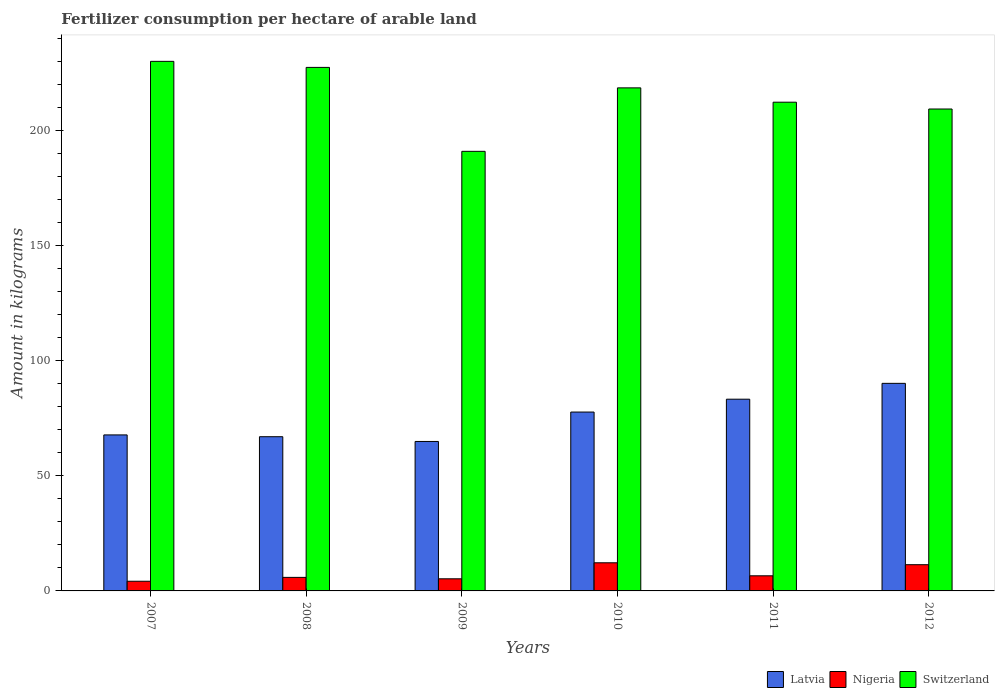How many different coloured bars are there?
Provide a succinct answer. 3. Are the number of bars per tick equal to the number of legend labels?
Keep it short and to the point. Yes. Are the number of bars on each tick of the X-axis equal?
Make the answer very short. Yes. How many bars are there on the 4th tick from the right?
Your answer should be very brief. 3. What is the label of the 2nd group of bars from the left?
Your answer should be compact. 2008. In how many cases, is the number of bars for a given year not equal to the number of legend labels?
Keep it short and to the point. 0. What is the amount of fertilizer consumption in Switzerland in 2012?
Your answer should be compact. 209.21. Across all years, what is the maximum amount of fertilizer consumption in Nigeria?
Provide a short and direct response. 12.21. Across all years, what is the minimum amount of fertilizer consumption in Switzerland?
Your response must be concise. 190.83. In which year was the amount of fertilizer consumption in Nigeria maximum?
Your answer should be very brief. 2010. In which year was the amount of fertilizer consumption in Switzerland minimum?
Your response must be concise. 2009. What is the total amount of fertilizer consumption in Latvia in the graph?
Your answer should be very brief. 450.55. What is the difference between the amount of fertilizer consumption in Latvia in 2009 and that in 2011?
Provide a short and direct response. -18.35. What is the difference between the amount of fertilizer consumption in Switzerland in 2011 and the amount of fertilizer consumption in Latvia in 2008?
Keep it short and to the point. 145.22. What is the average amount of fertilizer consumption in Switzerland per year?
Your response must be concise. 214.63. In the year 2009, what is the difference between the amount of fertilizer consumption in Switzerland and amount of fertilizer consumption in Latvia?
Your answer should be compact. 125.95. In how many years, is the amount of fertilizer consumption in Switzerland greater than 30 kg?
Offer a very short reply. 6. What is the ratio of the amount of fertilizer consumption in Nigeria in 2008 to that in 2009?
Make the answer very short. 1.12. Is the amount of fertilizer consumption in Switzerland in 2010 less than that in 2011?
Offer a very short reply. No. Is the difference between the amount of fertilizer consumption in Switzerland in 2010 and 2012 greater than the difference between the amount of fertilizer consumption in Latvia in 2010 and 2012?
Provide a succinct answer. Yes. What is the difference between the highest and the second highest amount of fertilizer consumption in Switzerland?
Offer a terse response. 2.62. What is the difference between the highest and the lowest amount of fertilizer consumption in Latvia?
Provide a succinct answer. 25.23. Is the sum of the amount of fertilizer consumption in Switzerland in 2007 and 2008 greater than the maximum amount of fertilizer consumption in Latvia across all years?
Your answer should be compact. Yes. What does the 2nd bar from the left in 2012 represents?
Your answer should be very brief. Nigeria. What does the 3rd bar from the right in 2012 represents?
Provide a short and direct response. Latvia. Does the graph contain any zero values?
Offer a very short reply. No. How many legend labels are there?
Ensure brevity in your answer.  3. How are the legend labels stacked?
Provide a succinct answer. Horizontal. What is the title of the graph?
Provide a succinct answer. Fertilizer consumption per hectare of arable land. What is the label or title of the X-axis?
Give a very brief answer. Years. What is the label or title of the Y-axis?
Provide a succinct answer. Amount in kilograms. What is the Amount in kilograms in Latvia in 2007?
Provide a short and direct response. 67.72. What is the Amount in kilograms in Nigeria in 2007?
Ensure brevity in your answer.  4.21. What is the Amount in kilograms in Switzerland in 2007?
Your response must be concise. 229.9. What is the Amount in kilograms of Latvia in 2008?
Give a very brief answer. 66.95. What is the Amount in kilograms of Nigeria in 2008?
Offer a very short reply. 5.88. What is the Amount in kilograms of Switzerland in 2008?
Offer a very short reply. 227.27. What is the Amount in kilograms of Latvia in 2009?
Offer a terse response. 64.88. What is the Amount in kilograms of Nigeria in 2009?
Ensure brevity in your answer.  5.26. What is the Amount in kilograms of Switzerland in 2009?
Give a very brief answer. 190.83. What is the Amount in kilograms in Latvia in 2010?
Provide a short and direct response. 77.65. What is the Amount in kilograms of Nigeria in 2010?
Offer a terse response. 12.21. What is the Amount in kilograms in Switzerland in 2010?
Offer a terse response. 218.38. What is the Amount in kilograms of Latvia in 2011?
Give a very brief answer. 83.23. What is the Amount in kilograms of Nigeria in 2011?
Offer a very short reply. 6.56. What is the Amount in kilograms in Switzerland in 2011?
Make the answer very short. 212.16. What is the Amount in kilograms of Latvia in 2012?
Make the answer very short. 90.11. What is the Amount in kilograms of Nigeria in 2012?
Your answer should be compact. 11.38. What is the Amount in kilograms of Switzerland in 2012?
Provide a succinct answer. 209.21. Across all years, what is the maximum Amount in kilograms in Latvia?
Offer a very short reply. 90.11. Across all years, what is the maximum Amount in kilograms of Nigeria?
Your answer should be compact. 12.21. Across all years, what is the maximum Amount in kilograms in Switzerland?
Ensure brevity in your answer.  229.9. Across all years, what is the minimum Amount in kilograms in Latvia?
Ensure brevity in your answer.  64.88. Across all years, what is the minimum Amount in kilograms of Nigeria?
Keep it short and to the point. 4.21. Across all years, what is the minimum Amount in kilograms of Switzerland?
Keep it short and to the point. 190.83. What is the total Amount in kilograms in Latvia in the graph?
Offer a very short reply. 450.55. What is the total Amount in kilograms in Nigeria in the graph?
Your answer should be compact. 45.5. What is the total Amount in kilograms of Switzerland in the graph?
Your response must be concise. 1287.75. What is the difference between the Amount in kilograms in Latvia in 2007 and that in 2008?
Your answer should be compact. 0.78. What is the difference between the Amount in kilograms of Nigeria in 2007 and that in 2008?
Provide a short and direct response. -1.67. What is the difference between the Amount in kilograms of Switzerland in 2007 and that in 2008?
Keep it short and to the point. 2.62. What is the difference between the Amount in kilograms of Latvia in 2007 and that in 2009?
Provide a succinct answer. 2.84. What is the difference between the Amount in kilograms in Nigeria in 2007 and that in 2009?
Keep it short and to the point. -1.06. What is the difference between the Amount in kilograms in Switzerland in 2007 and that in 2009?
Your answer should be compact. 39.07. What is the difference between the Amount in kilograms of Latvia in 2007 and that in 2010?
Your response must be concise. -9.92. What is the difference between the Amount in kilograms of Nigeria in 2007 and that in 2010?
Your answer should be very brief. -8.01. What is the difference between the Amount in kilograms in Switzerland in 2007 and that in 2010?
Provide a succinct answer. 11.51. What is the difference between the Amount in kilograms of Latvia in 2007 and that in 2011?
Your answer should be very brief. -15.51. What is the difference between the Amount in kilograms in Nigeria in 2007 and that in 2011?
Give a very brief answer. -2.36. What is the difference between the Amount in kilograms in Switzerland in 2007 and that in 2011?
Your response must be concise. 17.73. What is the difference between the Amount in kilograms of Latvia in 2007 and that in 2012?
Make the answer very short. -22.39. What is the difference between the Amount in kilograms of Nigeria in 2007 and that in 2012?
Offer a very short reply. -7.18. What is the difference between the Amount in kilograms in Switzerland in 2007 and that in 2012?
Offer a very short reply. 20.69. What is the difference between the Amount in kilograms in Latvia in 2008 and that in 2009?
Your answer should be very brief. 2.06. What is the difference between the Amount in kilograms in Nigeria in 2008 and that in 2009?
Your response must be concise. 0.62. What is the difference between the Amount in kilograms of Switzerland in 2008 and that in 2009?
Provide a short and direct response. 36.44. What is the difference between the Amount in kilograms in Latvia in 2008 and that in 2010?
Offer a terse response. -10.7. What is the difference between the Amount in kilograms of Nigeria in 2008 and that in 2010?
Give a very brief answer. -6.34. What is the difference between the Amount in kilograms of Switzerland in 2008 and that in 2010?
Provide a succinct answer. 8.89. What is the difference between the Amount in kilograms in Latvia in 2008 and that in 2011?
Offer a terse response. -16.29. What is the difference between the Amount in kilograms in Nigeria in 2008 and that in 2011?
Your response must be concise. -0.68. What is the difference between the Amount in kilograms in Switzerland in 2008 and that in 2011?
Offer a very short reply. 15.11. What is the difference between the Amount in kilograms in Latvia in 2008 and that in 2012?
Keep it short and to the point. -23.16. What is the difference between the Amount in kilograms of Nigeria in 2008 and that in 2012?
Make the answer very short. -5.51. What is the difference between the Amount in kilograms of Switzerland in 2008 and that in 2012?
Offer a terse response. 18.07. What is the difference between the Amount in kilograms in Latvia in 2009 and that in 2010?
Make the answer very short. -12.76. What is the difference between the Amount in kilograms of Nigeria in 2009 and that in 2010?
Your response must be concise. -6.95. What is the difference between the Amount in kilograms of Switzerland in 2009 and that in 2010?
Give a very brief answer. -27.55. What is the difference between the Amount in kilograms of Latvia in 2009 and that in 2011?
Your answer should be compact. -18.35. What is the difference between the Amount in kilograms in Nigeria in 2009 and that in 2011?
Provide a short and direct response. -1.3. What is the difference between the Amount in kilograms of Switzerland in 2009 and that in 2011?
Make the answer very short. -21.33. What is the difference between the Amount in kilograms of Latvia in 2009 and that in 2012?
Provide a short and direct response. -25.23. What is the difference between the Amount in kilograms in Nigeria in 2009 and that in 2012?
Keep it short and to the point. -6.12. What is the difference between the Amount in kilograms in Switzerland in 2009 and that in 2012?
Your answer should be very brief. -18.38. What is the difference between the Amount in kilograms in Latvia in 2010 and that in 2011?
Keep it short and to the point. -5.58. What is the difference between the Amount in kilograms in Nigeria in 2010 and that in 2011?
Your answer should be compact. 5.65. What is the difference between the Amount in kilograms of Switzerland in 2010 and that in 2011?
Provide a short and direct response. 6.22. What is the difference between the Amount in kilograms in Latvia in 2010 and that in 2012?
Your answer should be compact. -12.46. What is the difference between the Amount in kilograms in Nigeria in 2010 and that in 2012?
Keep it short and to the point. 0.83. What is the difference between the Amount in kilograms in Switzerland in 2010 and that in 2012?
Your answer should be very brief. 9.18. What is the difference between the Amount in kilograms of Latvia in 2011 and that in 2012?
Ensure brevity in your answer.  -6.88. What is the difference between the Amount in kilograms of Nigeria in 2011 and that in 2012?
Give a very brief answer. -4.82. What is the difference between the Amount in kilograms in Switzerland in 2011 and that in 2012?
Ensure brevity in your answer.  2.96. What is the difference between the Amount in kilograms of Latvia in 2007 and the Amount in kilograms of Nigeria in 2008?
Keep it short and to the point. 61.85. What is the difference between the Amount in kilograms of Latvia in 2007 and the Amount in kilograms of Switzerland in 2008?
Ensure brevity in your answer.  -159.55. What is the difference between the Amount in kilograms in Nigeria in 2007 and the Amount in kilograms in Switzerland in 2008?
Provide a short and direct response. -223.07. What is the difference between the Amount in kilograms of Latvia in 2007 and the Amount in kilograms of Nigeria in 2009?
Ensure brevity in your answer.  62.46. What is the difference between the Amount in kilograms in Latvia in 2007 and the Amount in kilograms in Switzerland in 2009?
Ensure brevity in your answer.  -123.11. What is the difference between the Amount in kilograms of Nigeria in 2007 and the Amount in kilograms of Switzerland in 2009?
Provide a succinct answer. -186.62. What is the difference between the Amount in kilograms in Latvia in 2007 and the Amount in kilograms in Nigeria in 2010?
Keep it short and to the point. 55.51. What is the difference between the Amount in kilograms of Latvia in 2007 and the Amount in kilograms of Switzerland in 2010?
Your answer should be very brief. -150.66. What is the difference between the Amount in kilograms of Nigeria in 2007 and the Amount in kilograms of Switzerland in 2010?
Give a very brief answer. -214.18. What is the difference between the Amount in kilograms in Latvia in 2007 and the Amount in kilograms in Nigeria in 2011?
Give a very brief answer. 61.16. What is the difference between the Amount in kilograms of Latvia in 2007 and the Amount in kilograms of Switzerland in 2011?
Your answer should be very brief. -144.44. What is the difference between the Amount in kilograms of Nigeria in 2007 and the Amount in kilograms of Switzerland in 2011?
Offer a very short reply. -207.96. What is the difference between the Amount in kilograms of Latvia in 2007 and the Amount in kilograms of Nigeria in 2012?
Your answer should be compact. 56.34. What is the difference between the Amount in kilograms in Latvia in 2007 and the Amount in kilograms in Switzerland in 2012?
Keep it short and to the point. -141.48. What is the difference between the Amount in kilograms in Nigeria in 2007 and the Amount in kilograms in Switzerland in 2012?
Your answer should be compact. -205. What is the difference between the Amount in kilograms in Latvia in 2008 and the Amount in kilograms in Nigeria in 2009?
Keep it short and to the point. 61.69. What is the difference between the Amount in kilograms in Latvia in 2008 and the Amount in kilograms in Switzerland in 2009?
Make the answer very short. -123.88. What is the difference between the Amount in kilograms of Nigeria in 2008 and the Amount in kilograms of Switzerland in 2009?
Provide a succinct answer. -184.95. What is the difference between the Amount in kilograms in Latvia in 2008 and the Amount in kilograms in Nigeria in 2010?
Provide a succinct answer. 54.73. What is the difference between the Amount in kilograms of Latvia in 2008 and the Amount in kilograms of Switzerland in 2010?
Offer a very short reply. -151.44. What is the difference between the Amount in kilograms of Nigeria in 2008 and the Amount in kilograms of Switzerland in 2010?
Your answer should be compact. -212.51. What is the difference between the Amount in kilograms in Latvia in 2008 and the Amount in kilograms in Nigeria in 2011?
Your response must be concise. 60.39. What is the difference between the Amount in kilograms of Latvia in 2008 and the Amount in kilograms of Switzerland in 2011?
Offer a very short reply. -145.22. What is the difference between the Amount in kilograms of Nigeria in 2008 and the Amount in kilograms of Switzerland in 2011?
Your answer should be very brief. -206.29. What is the difference between the Amount in kilograms in Latvia in 2008 and the Amount in kilograms in Nigeria in 2012?
Provide a short and direct response. 55.56. What is the difference between the Amount in kilograms in Latvia in 2008 and the Amount in kilograms in Switzerland in 2012?
Keep it short and to the point. -142.26. What is the difference between the Amount in kilograms of Nigeria in 2008 and the Amount in kilograms of Switzerland in 2012?
Offer a very short reply. -203.33. What is the difference between the Amount in kilograms in Latvia in 2009 and the Amount in kilograms in Nigeria in 2010?
Provide a succinct answer. 52.67. What is the difference between the Amount in kilograms in Latvia in 2009 and the Amount in kilograms in Switzerland in 2010?
Provide a succinct answer. -153.5. What is the difference between the Amount in kilograms in Nigeria in 2009 and the Amount in kilograms in Switzerland in 2010?
Your response must be concise. -213.12. What is the difference between the Amount in kilograms of Latvia in 2009 and the Amount in kilograms of Nigeria in 2011?
Your answer should be compact. 58.32. What is the difference between the Amount in kilograms of Latvia in 2009 and the Amount in kilograms of Switzerland in 2011?
Keep it short and to the point. -147.28. What is the difference between the Amount in kilograms of Nigeria in 2009 and the Amount in kilograms of Switzerland in 2011?
Offer a very short reply. -206.9. What is the difference between the Amount in kilograms in Latvia in 2009 and the Amount in kilograms in Nigeria in 2012?
Your answer should be very brief. 53.5. What is the difference between the Amount in kilograms of Latvia in 2009 and the Amount in kilograms of Switzerland in 2012?
Offer a terse response. -144.32. What is the difference between the Amount in kilograms of Nigeria in 2009 and the Amount in kilograms of Switzerland in 2012?
Give a very brief answer. -203.95. What is the difference between the Amount in kilograms in Latvia in 2010 and the Amount in kilograms in Nigeria in 2011?
Your response must be concise. 71.09. What is the difference between the Amount in kilograms of Latvia in 2010 and the Amount in kilograms of Switzerland in 2011?
Your response must be concise. -134.52. What is the difference between the Amount in kilograms in Nigeria in 2010 and the Amount in kilograms in Switzerland in 2011?
Give a very brief answer. -199.95. What is the difference between the Amount in kilograms in Latvia in 2010 and the Amount in kilograms in Nigeria in 2012?
Keep it short and to the point. 66.26. What is the difference between the Amount in kilograms of Latvia in 2010 and the Amount in kilograms of Switzerland in 2012?
Offer a very short reply. -131.56. What is the difference between the Amount in kilograms of Nigeria in 2010 and the Amount in kilograms of Switzerland in 2012?
Give a very brief answer. -196.99. What is the difference between the Amount in kilograms of Latvia in 2011 and the Amount in kilograms of Nigeria in 2012?
Your answer should be very brief. 71.85. What is the difference between the Amount in kilograms of Latvia in 2011 and the Amount in kilograms of Switzerland in 2012?
Provide a short and direct response. -125.98. What is the difference between the Amount in kilograms in Nigeria in 2011 and the Amount in kilograms in Switzerland in 2012?
Your response must be concise. -202.65. What is the average Amount in kilograms in Latvia per year?
Provide a succinct answer. 75.09. What is the average Amount in kilograms of Nigeria per year?
Offer a very short reply. 7.58. What is the average Amount in kilograms of Switzerland per year?
Keep it short and to the point. 214.63. In the year 2007, what is the difference between the Amount in kilograms in Latvia and Amount in kilograms in Nigeria?
Keep it short and to the point. 63.52. In the year 2007, what is the difference between the Amount in kilograms in Latvia and Amount in kilograms in Switzerland?
Your answer should be compact. -162.17. In the year 2007, what is the difference between the Amount in kilograms of Nigeria and Amount in kilograms of Switzerland?
Give a very brief answer. -225.69. In the year 2008, what is the difference between the Amount in kilograms of Latvia and Amount in kilograms of Nigeria?
Your answer should be compact. 61.07. In the year 2008, what is the difference between the Amount in kilograms in Latvia and Amount in kilograms in Switzerland?
Ensure brevity in your answer.  -160.33. In the year 2008, what is the difference between the Amount in kilograms of Nigeria and Amount in kilograms of Switzerland?
Your answer should be compact. -221.4. In the year 2009, what is the difference between the Amount in kilograms of Latvia and Amount in kilograms of Nigeria?
Ensure brevity in your answer.  59.62. In the year 2009, what is the difference between the Amount in kilograms in Latvia and Amount in kilograms in Switzerland?
Provide a short and direct response. -125.95. In the year 2009, what is the difference between the Amount in kilograms of Nigeria and Amount in kilograms of Switzerland?
Your answer should be compact. -185.57. In the year 2010, what is the difference between the Amount in kilograms of Latvia and Amount in kilograms of Nigeria?
Provide a short and direct response. 65.43. In the year 2010, what is the difference between the Amount in kilograms of Latvia and Amount in kilograms of Switzerland?
Make the answer very short. -140.74. In the year 2010, what is the difference between the Amount in kilograms in Nigeria and Amount in kilograms in Switzerland?
Give a very brief answer. -206.17. In the year 2011, what is the difference between the Amount in kilograms of Latvia and Amount in kilograms of Nigeria?
Provide a succinct answer. 76.67. In the year 2011, what is the difference between the Amount in kilograms of Latvia and Amount in kilograms of Switzerland?
Ensure brevity in your answer.  -128.93. In the year 2011, what is the difference between the Amount in kilograms of Nigeria and Amount in kilograms of Switzerland?
Ensure brevity in your answer.  -205.6. In the year 2012, what is the difference between the Amount in kilograms in Latvia and Amount in kilograms in Nigeria?
Offer a very short reply. 78.73. In the year 2012, what is the difference between the Amount in kilograms of Latvia and Amount in kilograms of Switzerland?
Provide a short and direct response. -119.1. In the year 2012, what is the difference between the Amount in kilograms of Nigeria and Amount in kilograms of Switzerland?
Make the answer very short. -197.82. What is the ratio of the Amount in kilograms in Latvia in 2007 to that in 2008?
Give a very brief answer. 1.01. What is the ratio of the Amount in kilograms in Nigeria in 2007 to that in 2008?
Give a very brief answer. 0.72. What is the ratio of the Amount in kilograms in Switzerland in 2007 to that in 2008?
Ensure brevity in your answer.  1.01. What is the ratio of the Amount in kilograms of Latvia in 2007 to that in 2009?
Offer a terse response. 1.04. What is the ratio of the Amount in kilograms of Nigeria in 2007 to that in 2009?
Your answer should be very brief. 0.8. What is the ratio of the Amount in kilograms of Switzerland in 2007 to that in 2009?
Your response must be concise. 1.2. What is the ratio of the Amount in kilograms of Latvia in 2007 to that in 2010?
Provide a succinct answer. 0.87. What is the ratio of the Amount in kilograms in Nigeria in 2007 to that in 2010?
Ensure brevity in your answer.  0.34. What is the ratio of the Amount in kilograms in Switzerland in 2007 to that in 2010?
Give a very brief answer. 1.05. What is the ratio of the Amount in kilograms in Latvia in 2007 to that in 2011?
Your answer should be very brief. 0.81. What is the ratio of the Amount in kilograms in Nigeria in 2007 to that in 2011?
Provide a succinct answer. 0.64. What is the ratio of the Amount in kilograms in Switzerland in 2007 to that in 2011?
Your answer should be very brief. 1.08. What is the ratio of the Amount in kilograms in Latvia in 2007 to that in 2012?
Provide a succinct answer. 0.75. What is the ratio of the Amount in kilograms of Nigeria in 2007 to that in 2012?
Make the answer very short. 0.37. What is the ratio of the Amount in kilograms in Switzerland in 2007 to that in 2012?
Your response must be concise. 1.1. What is the ratio of the Amount in kilograms in Latvia in 2008 to that in 2009?
Make the answer very short. 1.03. What is the ratio of the Amount in kilograms in Nigeria in 2008 to that in 2009?
Make the answer very short. 1.12. What is the ratio of the Amount in kilograms of Switzerland in 2008 to that in 2009?
Offer a terse response. 1.19. What is the ratio of the Amount in kilograms of Latvia in 2008 to that in 2010?
Your answer should be very brief. 0.86. What is the ratio of the Amount in kilograms of Nigeria in 2008 to that in 2010?
Provide a short and direct response. 0.48. What is the ratio of the Amount in kilograms in Switzerland in 2008 to that in 2010?
Your answer should be compact. 1.04. What is the ratio of the Amount in kilograms of Latvia in 2008 to that in 2011?
Your response must be concise. 0.8. What is the ratio of the Amount in kilograms in Nigeria in 2008 to that in 2011?
Provide a short and direct response. 0.9. What is the ratio of the Amount in kilograms in Switzerland in 2008 to that in 2011?
Your answer should be very brief. 1.07. What is the ratio of the Amount in kilograms of Latvia in 2008 to that in 2012?
Make the answer very short. 0.74. What is the ratio of the Amount in kilograms in Nigeria in 2008 to that in 2012?
Ensure brevity in your answer.  0.52. What is the ratio of the Amount in kilograms in Switzerland in 2008 to that in 2012?
Provide a short and direct response. 1.09. What is the ratio of the Amount in kilograms of Latvia in 2009 to that in 2010?
Ensure brevity in your answer.  0.84. What is the ratio of the Amount in kilograms of Nigeria in 2009 to that in 2010?
Give a very brief answer. 0.43. What is the ratio of the Amount in kilograms in Switzerland in 2009 to that in 2010?
Your answer should be very brief. 0.87. What is the ratio of the Amount in kilograms in Latvia in 2009 to that in 2011?
Your answer should be very brief. 0.78. What is the ratio of the Amount in kilograms in Nigeria in 2009 to that in 2011?
Provide a succinct answer. 0.8. What is the ratio of the Amount in kilograms of Switzerland in 2009 to that in 2011?
Provide a succinct answer. 0.9. What is the ratio of the Amount in kilograms of Latvia in 2009 to that in 2012?
Provide a succinct answer. 0.72. What is the ratio of the Amount in kilograms in Nigeria in 2009 to that in 2012?
Make the answer very short. 0.46. What is the ratio of the Amount in kilograms in Switzerland in 2009 to that in 2012?
Your response must be concise. 0.91. What is the ratio of the Amount in kilograms in Latvia in 2010 to that in 2011?
Offer a terse response. 0.93. What is the ratio of the Amount in kilograms in Nigeria in 2010 to that in 2011?
Your answer should be compact. 1.86. What is the ratio of the Amount in kilograms in Switzerland in 2010 to that in 2011?
Your response must be concise. 1.03. What is the ratio of the Amount in kilograms of Latvia in 2010 to that in 2012?
Give a very brief answer. 0.86. What is the ratio of the Amount in kilograms in Nigeria in 2010 to that in 2012?
Make the answer very short. 1.07. What is the ratio of the Amount in kilograms of Switzerland in 2010 to that in 2012?
Keep it short and to the point. 1.04. What is the ratio of the Amount in kilograms of Latvia in 2011 to that in 2012?
Give a very brief answer. 0.92. What is the ratio of the Amount in kilograms in Nigeria in 2011 to that in 2012?
Keep it short and to the point. 0.58. What is the ratio of the Amount in kilograms of Switzerland in 2011 to that in 2012?
Make the answer very short. 1.01. What is the difference between the highest and the second highest Amount in kilograms of Latvia?
Keep it short and to the point. 6.88. What is the difference between the highest and the second highest Amount in kilograms of Nigeria?
Your response must be concise. 0.83. What is the difference between the highest and the second highest Amount in kilograms in Switzerland?
Ensure brevity in your answer.  2.62. What is the difference between the highest and the lowest Amount in kilograms in Latvia?
Your answer should be very brief. 25.23. What is the difference between the highest and the lowest Amount in kilograms of Nigeria?
Make the answer very short. 8.01. What is the difference between the highest and the lowest Amount in kilograms of Switzerland?
Provide a short and direct response. 39.07. 